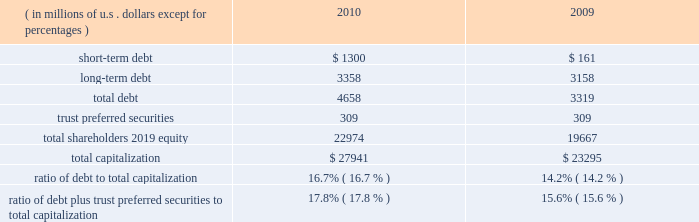Our consolidated net cash flows used for investing activities were $ 4.2 billion in 2010 , compared with $ 3.2 billion in 2009 .
Net investing activities for the indicated periods were related primarily to net purchases of fixed maturities and for 2010 included the acquisitions of rain and hail and jerneh insurance berhad .
Our consolidated net cash flows from financing activities were $ 732 million in 2010 , compared with net cash flows used for financing activities of $ 321 million in 2009 .
Net cash flows from/used for financing activities in 2010 and 2009 , included dividends paid on our common shares of $ 435 million and $ 388 million , respectively .
Net cash flows from financing activ- ities in 2010 , included net proceeds of $ 699 million from the issuance of long-term debt , $ 1 billion in reverse repurchase agreements , and $ 300 million in credit facility borrowings .
This was partially offset by repayment of $ 659 million in debt and share repurchases settled in 2010 of $ 235 million .
For 2009 , net cash flows used for financing activities included net pro- ceeds from the issuance of $ 500 million in long-term debt and the net repayment of debt and reverse repurchase agreements of $ 466 million .
Both internal and external forces influence our financial condition , results of operations , and cash flows .
Claim settle- ments , premium levels , and investment returns may be impacted by changing rates of inflation and other economic conditions .
In many cases , significant periods of time , ranging up to several years or more , may lapse between the occurrence of an insured loss , the reporting of the loss to us , and the settlement of the liability for that loss .
From time to time , we utilize reverse repurchase agreements as a low-cost alternative for short-term funding needs .
We use these instruments on a limited basis to address short-term cash timing differences without disrupting our investment portfolio holdings and settle the transactions with future operating cash flows .
At december 31 , 2010 , there were $ 1 billion in reverse repurchase agreements outstanding ( refer to short-term debt ) .
In addition to cash from operations , routine sales of investments , and financing arrangements , we have agreements with a bank provider which implemented two international multi-currency notional cash pooling programs to enhance cash management efficiency during periods of short-term timing mismatches between expected inflows and outflows of cash by currency .
In each program , participating ace entities establish deposit accounts in different currencies with the bank provider and each day the credit or debit balances in every account are notionally translated into a single currency ( u.s .
Dollars ) and then notionally pooled .
The bank extends overdraft credit to any participating ace entity as needed , provided that the overall notionally-pooled balance of all accounts in each pool at the end of each day is at least zero .
Actual cash balances are not physically converted and are not co-mingled between legal entities .
Ace entities may incur overdraft balances as a means to address short-term timing mismatches , and any overdraft balances incurred under this program by an ace entity would be guaranteed by ace limited ( up to $ 150 million in the aggregate ) .
Our revolving credit facility allows for same day drawings to fund a net pool overdraft should participating ace entities withdraw contributed funds from the pool .
Capital resources capital resources consist of funds deployed or available to be deployed to support our business operations .
The table summarizes the components of our capital resources at december 31 , 2010 , and 2009. .
Our ratios of debt to total capitalization and debt plus trust preferred securities to total capitalization have increased temporarily due to the increase in short-term debt , as discussed below .
We expect that these ratios will decline over the next six to nine months as we repay the short-term debt .
We believe our financial strength provides us with the flexibility and capacity to obtain available funds externally through debt or equity financing on both a short-term and long-term basis .
Our ability to access the capital markets is dependent on , among other things , market conditions and our perceived financial strength .
We have accessed both the debt and equity markets from time to time. .
What was the percentage change in the consolidated net cash flows used for investing activities \\n from 2009 to 2010? 
Computations: ((4.2 - 3.2) / 3.2)
Answer: 0.3125. 